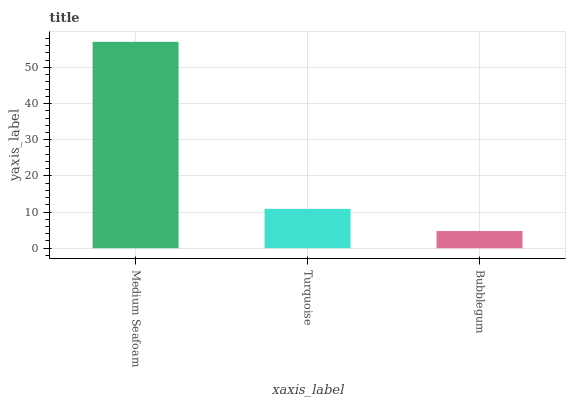Is Bubblegum the minimum?
Answer yes or no. Yes. Is Medium Seafoam the maximum?
Answer yes or no. Yes. Is Turquoise the minimum?
Answer yes or no. No. Is Turquoise the maximum?
Answer yes or no. No. Is Medium Seafoam greater than Turquoise?
Answer yes or no. Yes. Is Turquoise less than Medium Seafoam?
Answer yes or no. Yes. Is Turquoise greater than Medium Seafoam?
Answer yes or no. No. Is Medium Seafoam less than Turquoise?
Answer yes or no. No. Is Turquoise the high median?
Answer yes or no. Yes. Is Turquoise the low median?
Answer yes or no. Yes. Is Bubblegum the high median?
Answer yes or no. No. Is Bubblegum the low median?
Answer yes or no. No. 